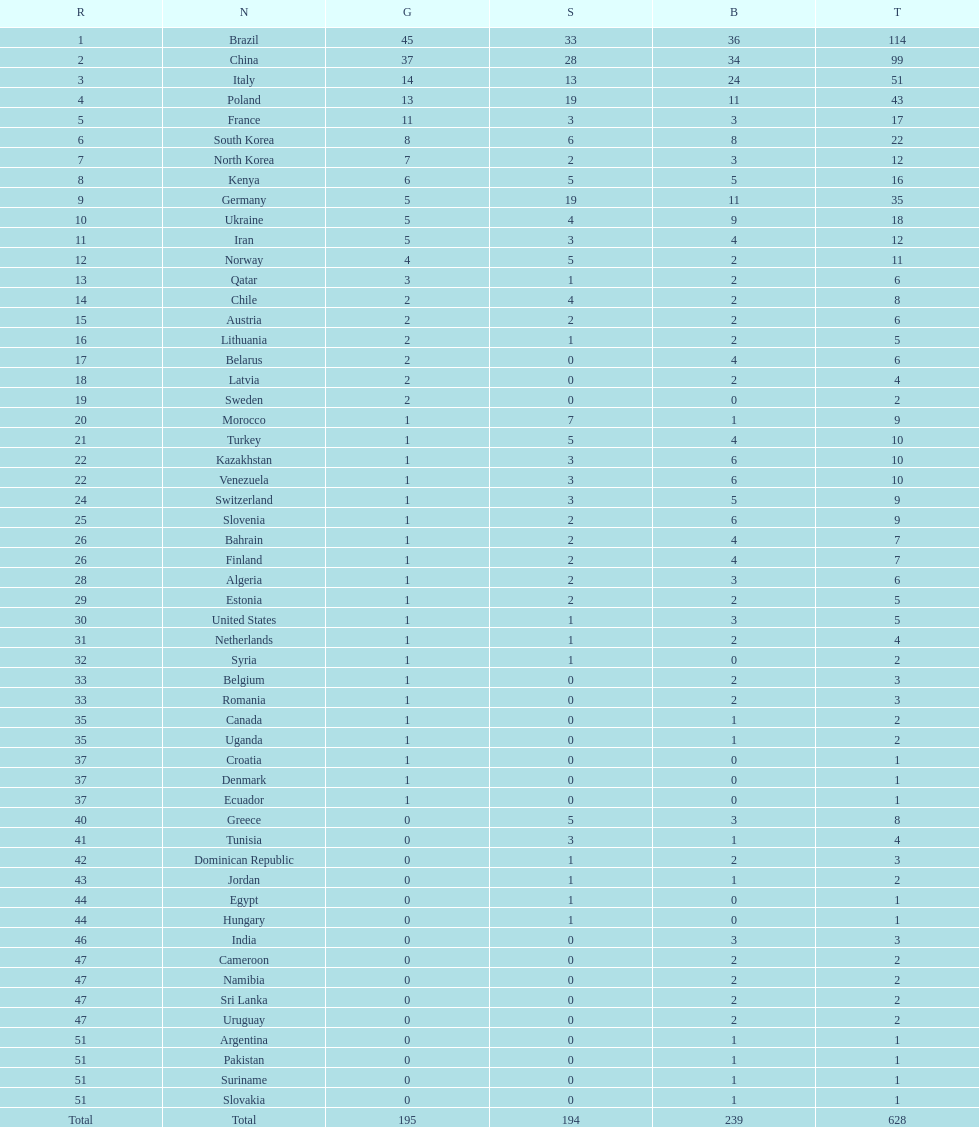How many gold medals did germany obtain? 5. 